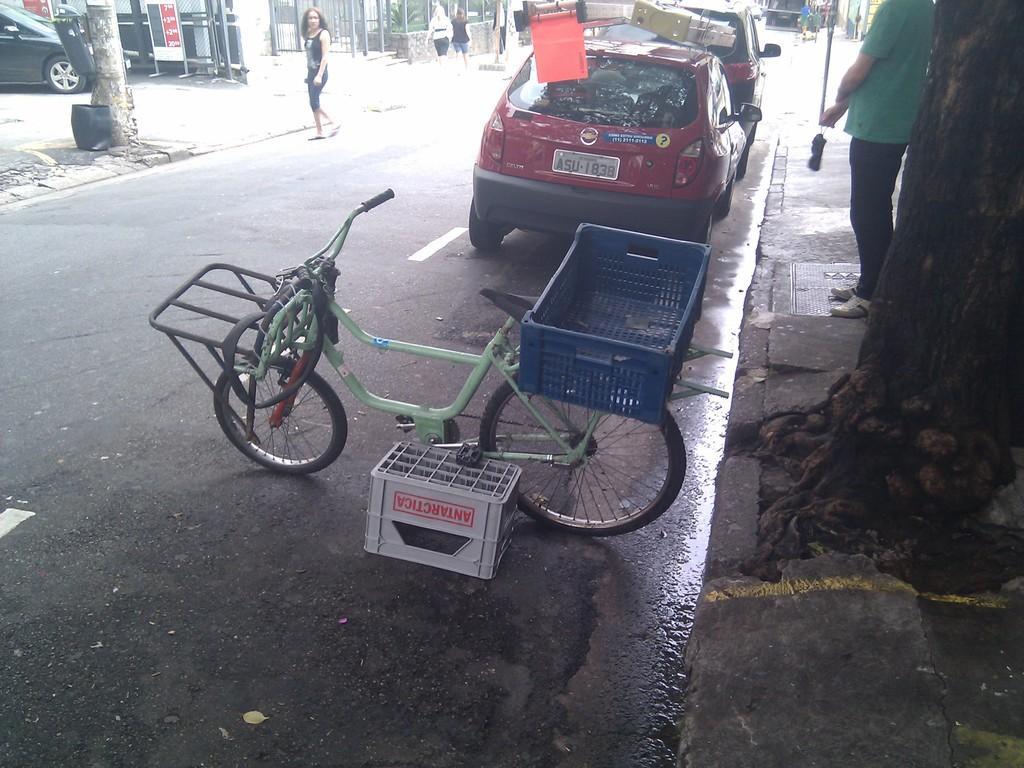In one or two sentences, can you explain what this image depicts? In the center of the image we can see a cycle and baskets. On the right side of the image, there is a tree and one person is standing and he is holding some object. In the background, we can see vehicles, few people and a few other objects. 